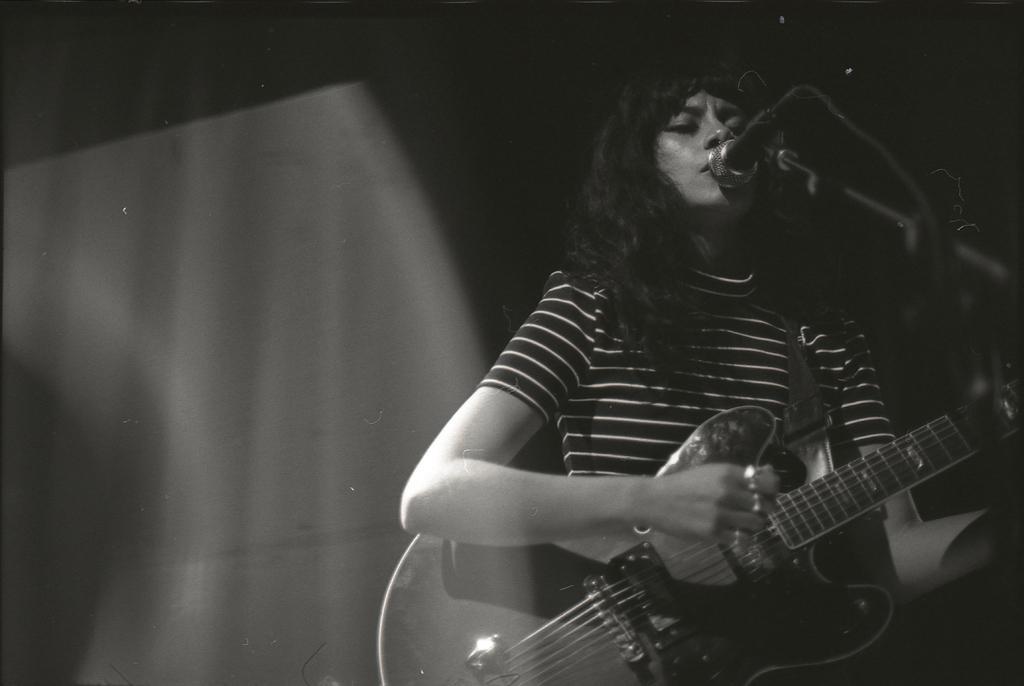How would you summarize this image in a sentence or two? This picture shows a woman singing in front of mic and a stand playing the guitar in her hands. In the background, there is dark. 